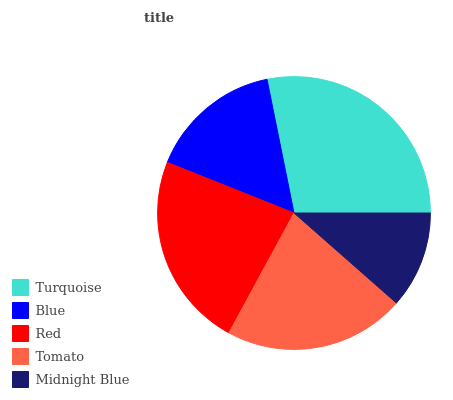Is Midnight Blue the minimum?
Answer yes or no. Yes. Is Turquoise the maximum?
Answer yes or no. Yes. Is Blue the minimum?
Answer yes or no. No. Is Blue the maximum?
Answer yes or no. No. Is Turquoise greater than Blue?
Answer yes or no. Yes. Is Blue less than Turquoise?
Answer yes or no. Yes. Is Blue greater than Turquoise?
Answer yes or no. No. Is Turquoise less than Blue?
Answer yes or no. No. Is Tomato the high median?
Answer yes or no. Yes. Is Tomato the low median?
Answer yes or no. Yes. Is Turquoise the high median?
Answer yes or no. No. Is Midnight Blue the low median?
Answer yes or no. No. 